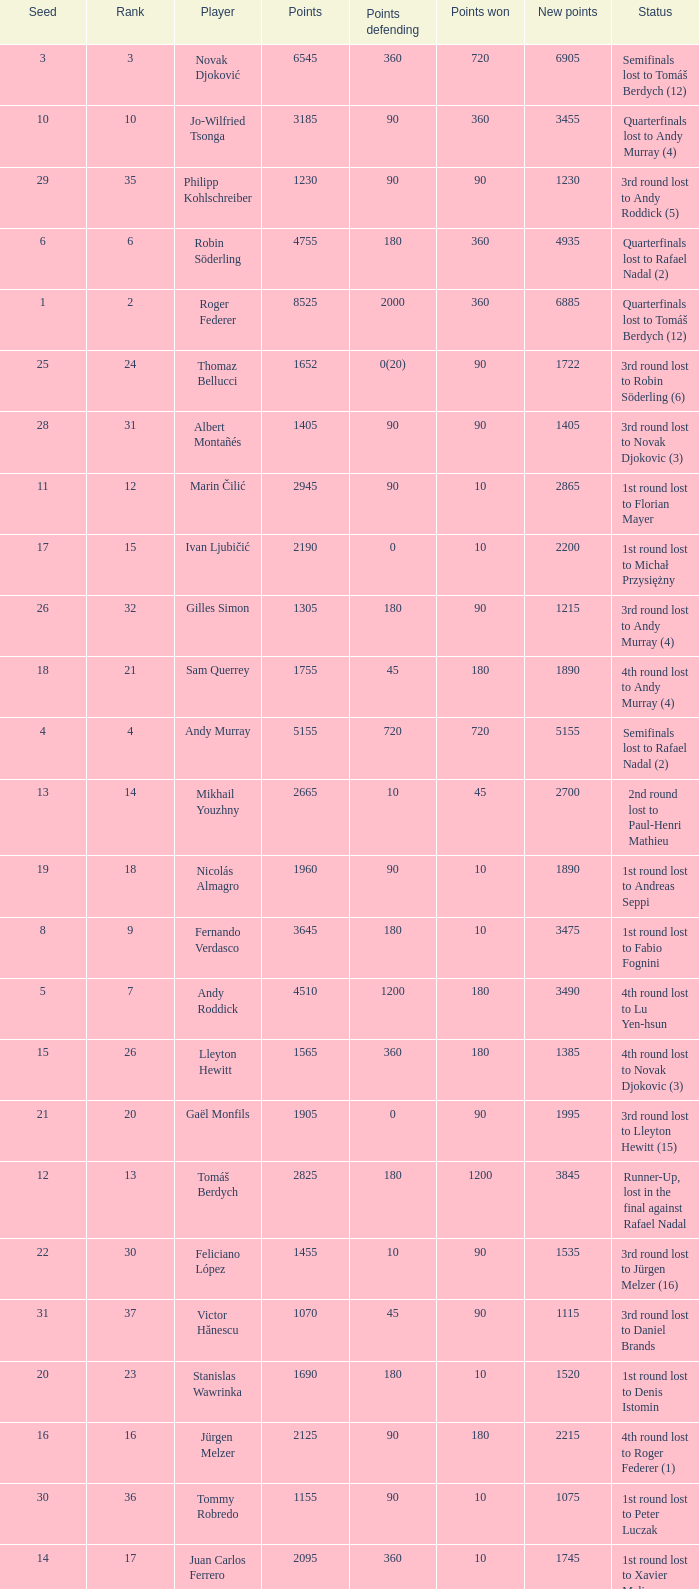Name the least new points for points defending is 1200 3490.0. 